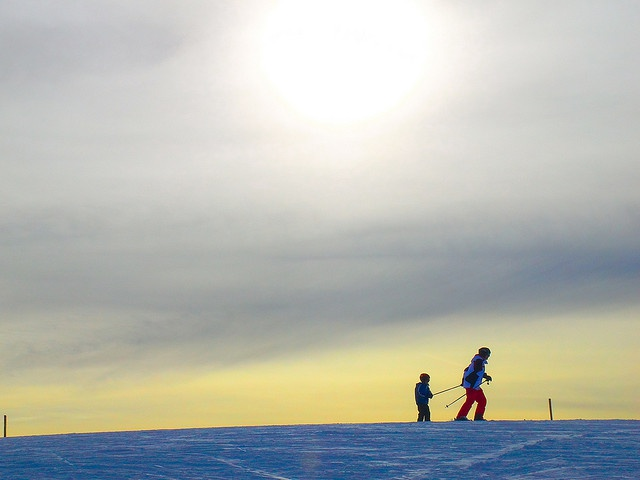Describe the objects in this image and their specific colors. I can see people in lightgray, maroon, black, khaki, and blue tones, people in lightgray, black, navy, khaki, and gray tones, and skis in lightgray, navy, teal, blue, and black tones in this image. 